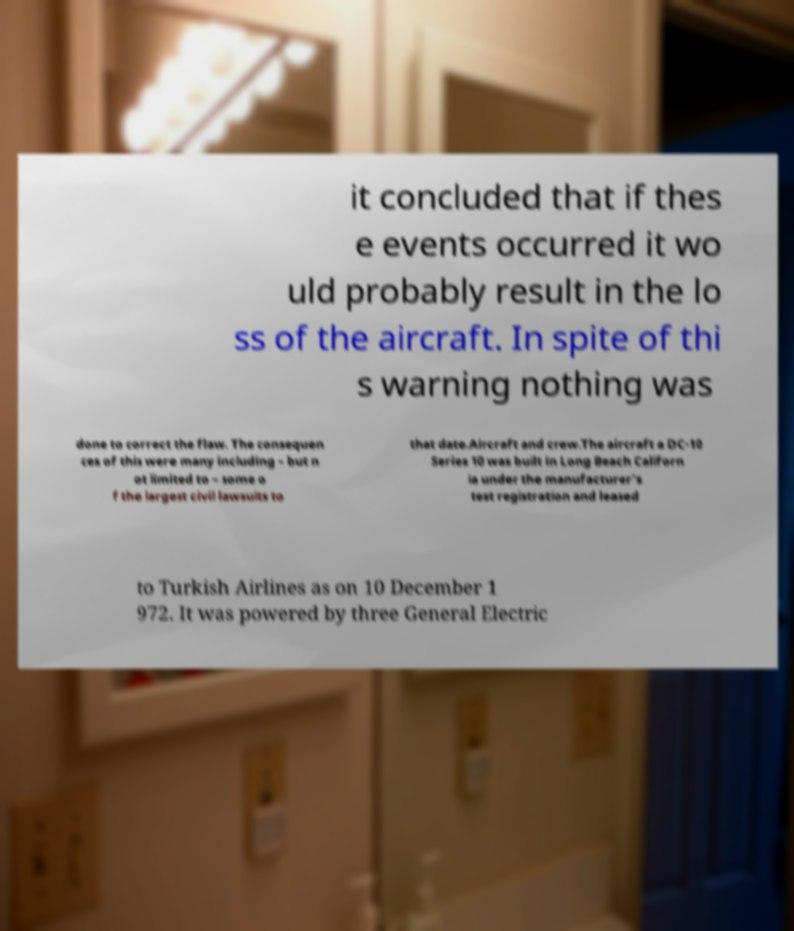Please identify and transcribe the text found in this image. it concluded that if thes e events occurred it wo uld probably result in the lo ss of the aircraft. In spite of thi s warning nothing was done to correct the flaw. The consequen ces of this were many including – but n ot limited to – some o f the largest civil lawsuits to that date.Aircraft and crew.The aircraft a DC-10 Series 10 was built in Long Beach Californ ia under the manufacturer's test registration and leased to Turkish Airlines as on 10 December 1 972. It was powered by three General Electric 